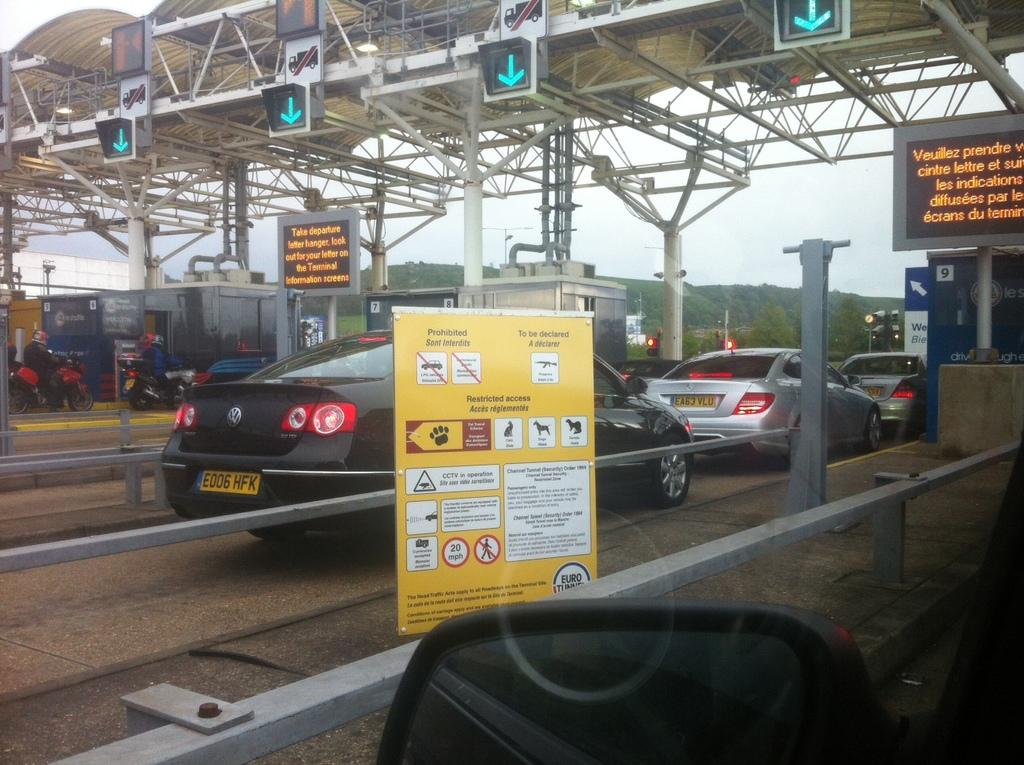Provide a one-sentence caption for the provided image. A check point for departure terminals to drive cars through. 